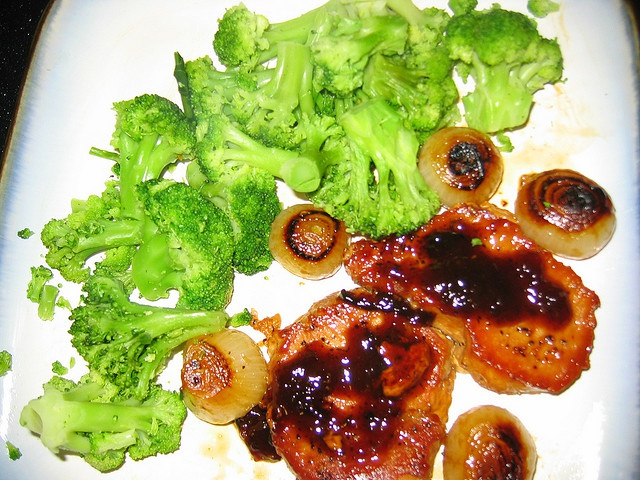Describe the objects in this image and their specific colors. I can see broccoli in black, lightgreen, green, and khaki tones, broccoli in black, lightgreen, and khaki tones, broccoli in black, olive, and lightgreen tones, and broccoli in black, green, khaki, and lightgreen tones in this image. 